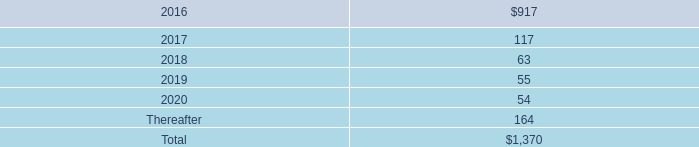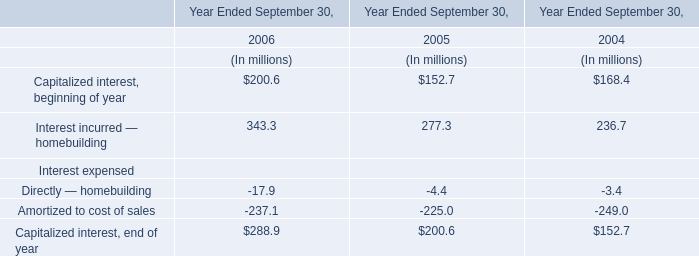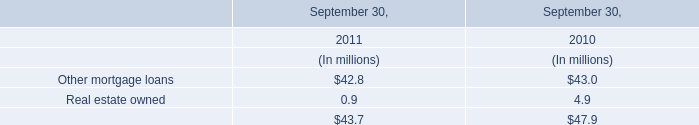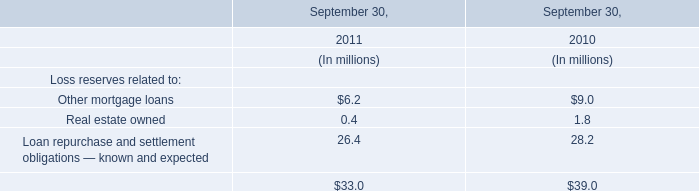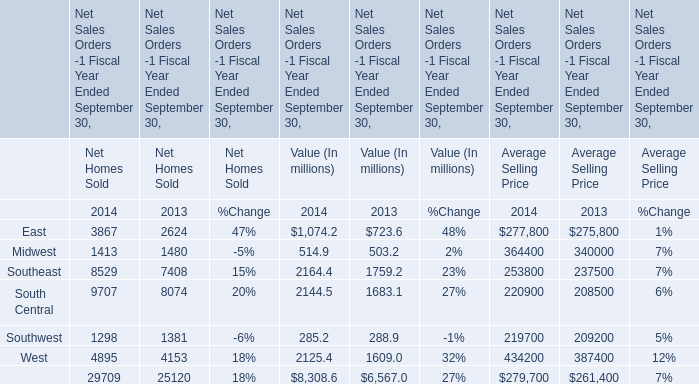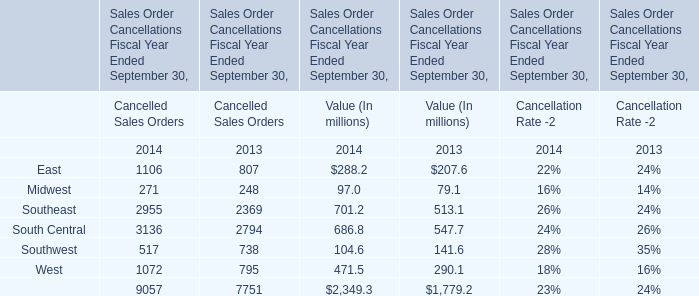In the year with the most East, what is the growth rate of Midwest? 
Computations: ((1413 - 1480) / 1413)
Answer: -0.04742. 